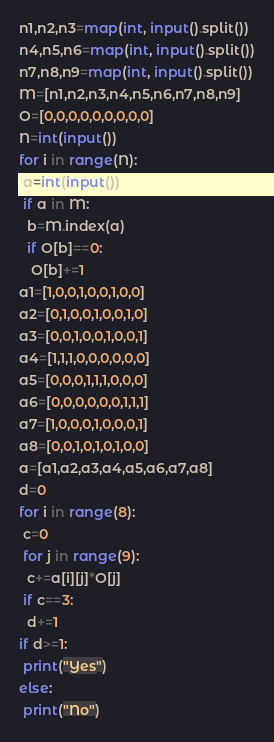<code> <loc_0><loc_0><loc_500><loc_500><_Python_>n1,n2,n3=map(int, input().split())
n4,n5,n6=map(int, input().split())
n7,n8,n9=map(int, input().split())
M=[n1,n2,n3,n4,n5,n6,n7,n8,n9]
O=[0,0,0,0,0,0,0,0,0]
N=int(input())
for i in range(N):
 a=int(input())
 if a in M:
  b=M.index(a)
  if O[b]==0:
   O[b]+=1
a1=[1,0,0,1,0,0,1,0,0]
a2=[0,1,0,0,1,0,0,1,0]
a3=[0,0,1,0,0,1,0,0,1]
a4=[1,1,1,0,0,0,0,0,0]
a5=[0,0,0,1,1,1,0,0,0]
a6=[0,0,0,0,0,0,1,1,1]
a7=[1,0,0,0,1,0,0,0,1]
a8=[0,0,1,0,1,0,1,0,0]
a=[a1,a2,a3,a4,a5,a6,a7,a8]
d=0
for i in range(8):
 c=0
 for j in range(9):
  c+=a[i][j]*O[j]
 if c==3:
  d+=1
if d>=1:
 print("Yes")
else:
 print("No")</code> 